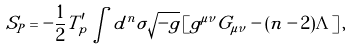Convert formula to latex. <formula><loc_0><loc_0><loc_500><loc_500>S _ { P } = - \frac { 1 } { 2 } T ^ { \prime } _ { p } \int d ^ { n } \sigma \sqrt { - g } \left [ g ^ { \mu \nu } G _ { \mu \nu } - ( n - 2 ) \Lambda \right ] ,</formula> 